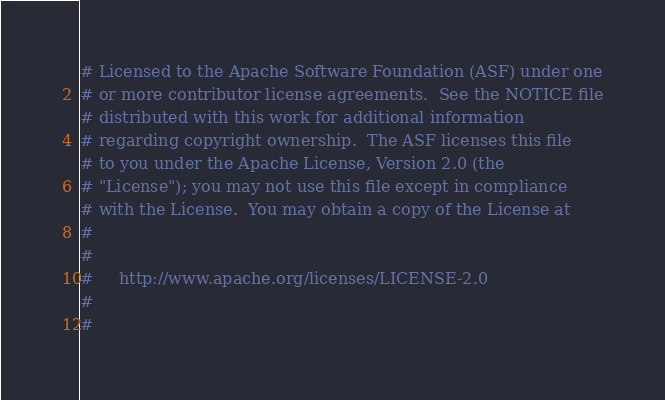<code> <loc_0><loc_0><loc_500><loc_500><_Python_># Licensed to the Apache Software Foundation (ASF) under one
# or more contributor license agreements.  See the NOTICE file
# distributed with this work for additional information
# regarding copyright ownership.  The ASF licenses this file
# to you under the Apache License, Version 2.0 (the
# "License"); you may not use this file except in compliance
# with the License.  You may obtain a copy of the License at
#
#
#     http://www.apache.org/licenses/LICENSE-2.0
#
#</code> 